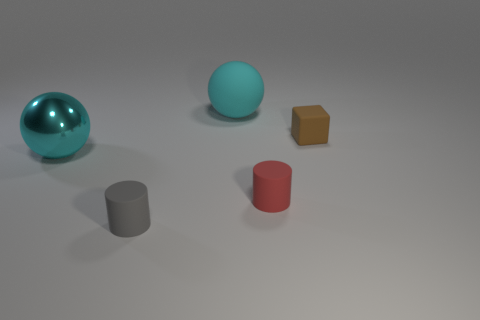What number of large cyan rubber objects have the same shape as the tiny brown thing?
Offer a terse response. 0. What is the material of the brown thing that is the same size as the gray cylinder?
Keep it short and to the point. Rubber. What size is the cyan object on the right side of the cyan ball on the left side of the big cyan thing that is behind the metal object?
Provide a short and direct response. Large. There is a small matte cylinder that is in front of the red rubber cylinder; is it the same color as the cylinder right of the cyan rubber ball?
Your answer should be very brief. No. How many cyan things are small cylinders or small objects?
Offer a very short reply. 0. How many blue rubber cubes have the same size as the gray rubber object?
Your answer should be compact. 0. Is the cyan object in front of the small brown rubber object made of the same material as the red cylinder?
Your answer should be compact. No. There is a large cyan rubber ball right of the tiny gray cylinder; are there any small red cylinders that are on the left side of it?
Offer a very short reply. No. What is the material of the other cyan object that is the same shape as the big cyan rubber object?
Provide a succinct answer. Metal. Are there more small brown things on the left side of the tiny red rubber cylinder than red cylinders behind the brown block?
Your answer should be compact. No. 